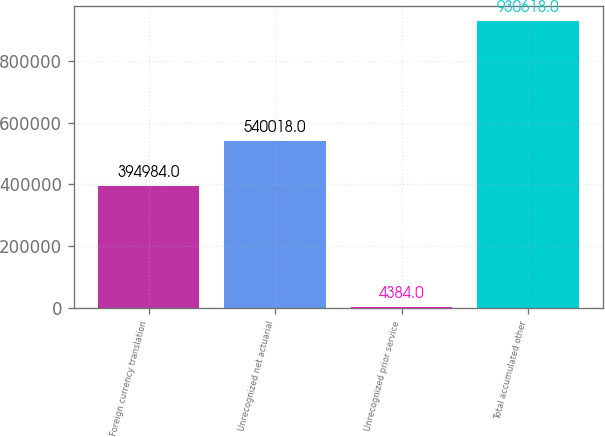Convert chart. <chart><loc_0><loc_0><loc_500><loc_500><bar_chart><fcel>Foreign currency translation<fcel>Unrecognized net actuarial<fcel>Unrecognized prior service<fcel>Total accumulated other<nl><fcel>394984<fcel>540018<fcel>4384<fcel>930618<nl></chart> 